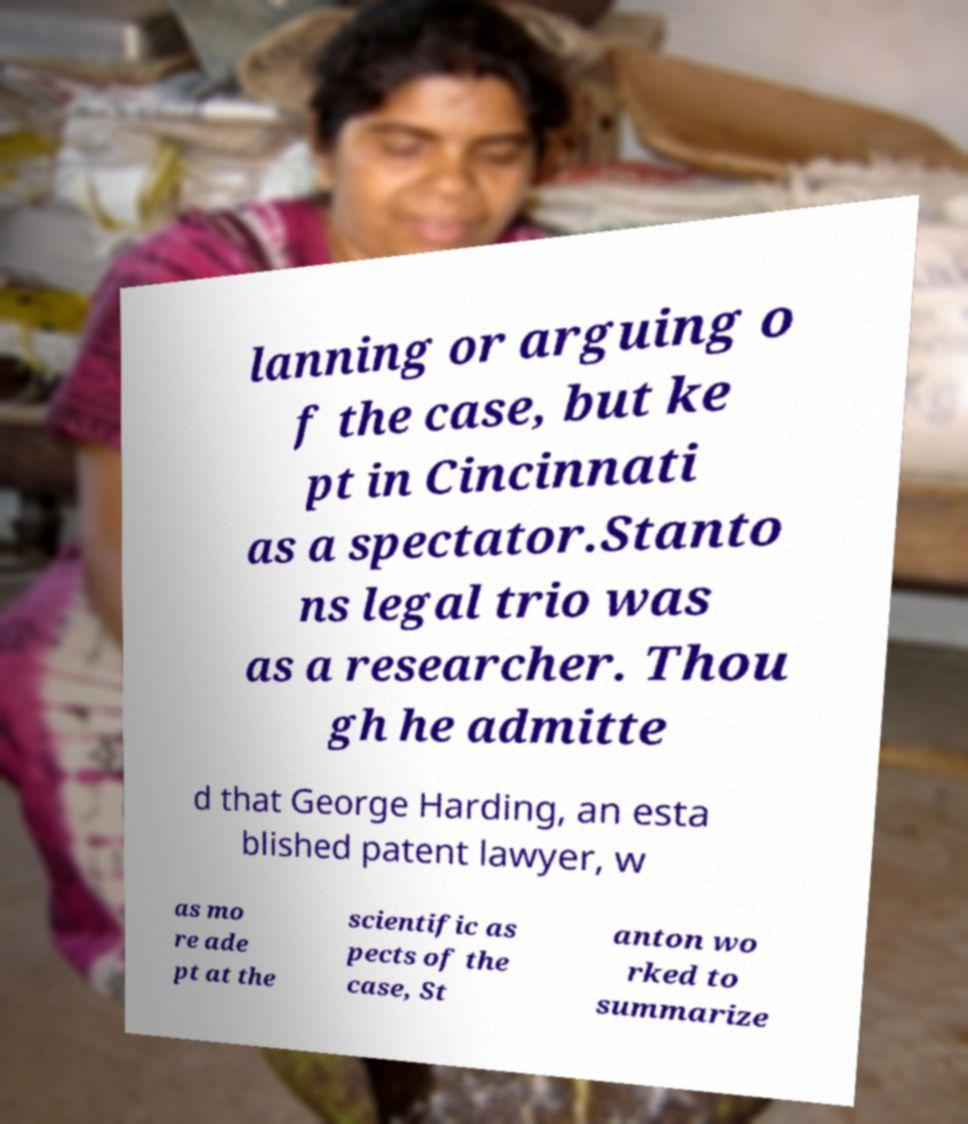There's text embedded in this image that I need extracted. Can you transcribe it verbatim? lanning or arguing o f the case, but ke pt in Cincinnati as a spectator.Stanto ns legal trio was as a researcher. Thou gh he admitte d that George Harding, an esta blished patent lawyer, w as mo re ade pt at the scientific as pects of the case, St anton wo rked to summarize 